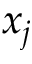Convert formula to latex. <formula><loc_0><loc_0><loc_500><loc_500>x _ { j }</formula> 